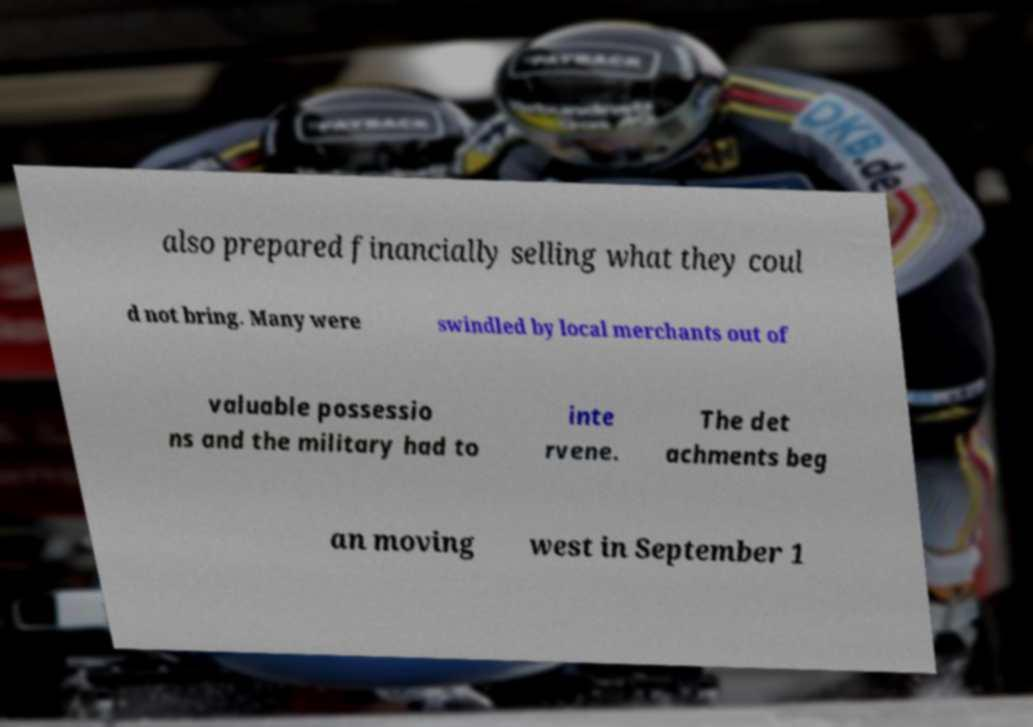What messages or text are displayed in this image? I need them in a readable, typed format. also prepared financially selling what they coul d not bring. Many were swindled by local merchants out of valuable possessio ns and the military had to inte rvene. The det achments beg an moving west in September 1 